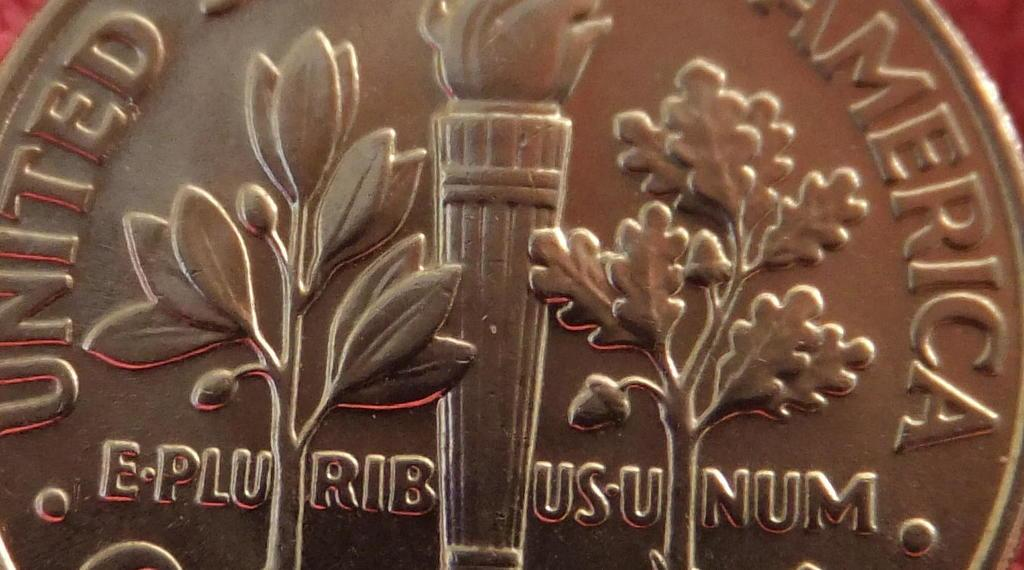What is the main subject of the image? The main subject of the image is a coin. What can be seen on the surface of the coin? The coin has a design of trees on its surface. Is there any text present on the coin? Yes, there is text written on the coin. What else can be seen in the image besides the coin? There is an object in the background of the image. How is the receipt being distributed in the image? There is no receipt present in the image, so it cannot be distributed. What type of bulb is illuminating the coin in the image? There is no bulb present in the image, and the coin is not illuminated. 